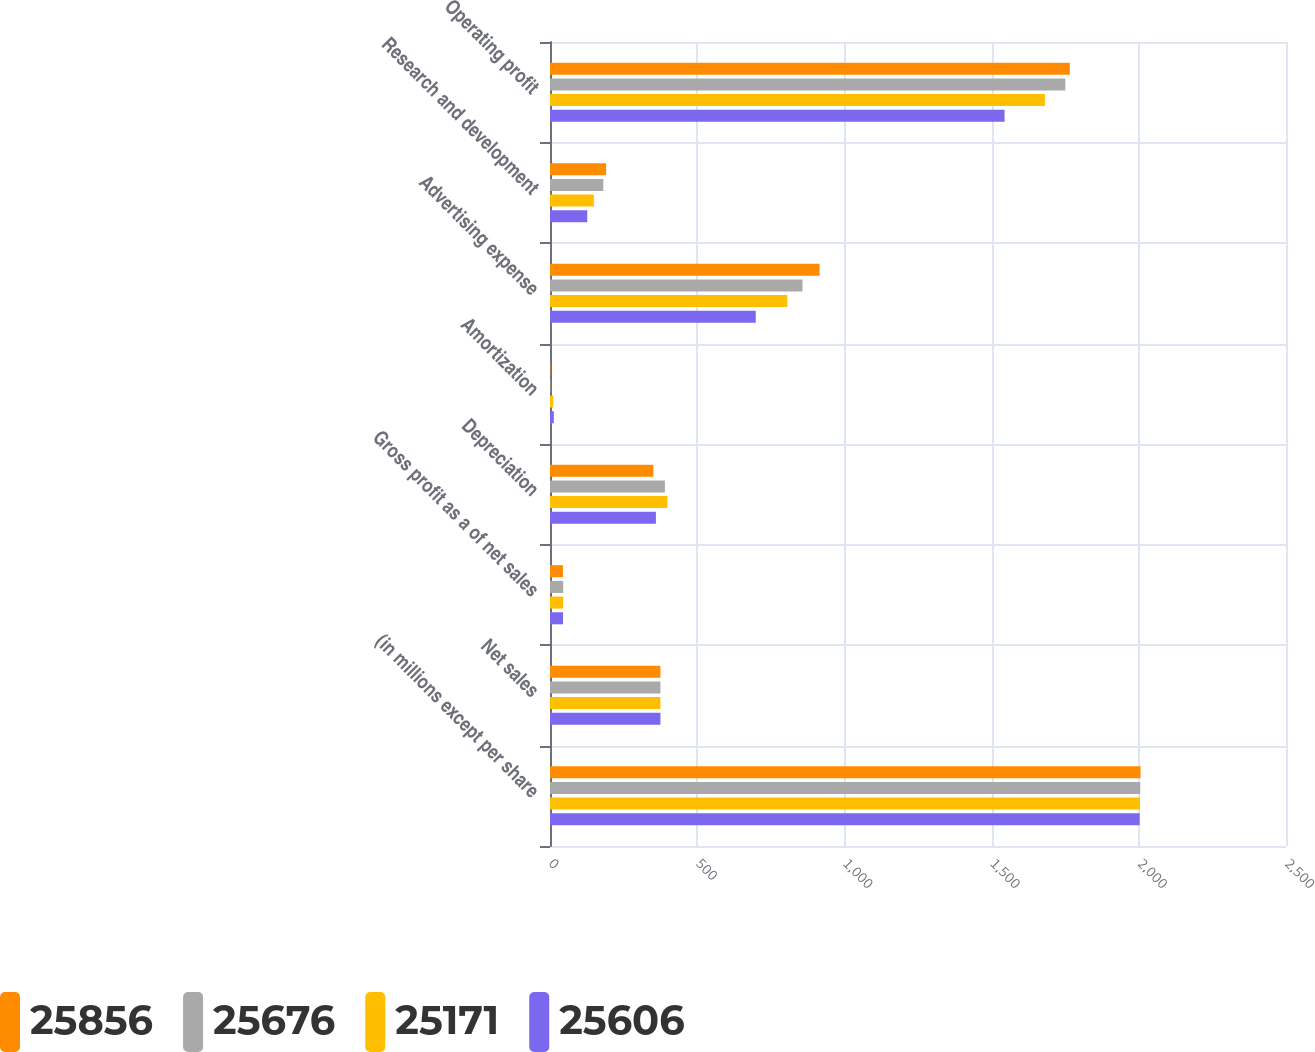Convert chart to OTSL. <chart><loc_0><loc_0><loc_500><loc_500><stacked_bar_chart><ecel><fcel>(in millions except per share<fcel>Net sales<fcel>Gross profit as a of net sales<fcel>Depreciation<fcel>Amortization<fcel>Advertising expense<fcel>Research and development<fcel>Operating profit<nl><fcel>25856<fcel>2006<fcel>375.05<fcel>44.2<fcel>351.2<fcel>1.5<fcel>915.9<fcel>190.6<fcel>1765.8<nl><fcel>25676<fcel>2005<fcel>375.05<fcel>44.9<fcel>390.3<fcel>1.5<fcel>857.7<fcel>181<fcel>1750.3<nl><fcel>25171<fcel>2004<fcel>375.05<fcel>44.9<fcel>399<fcel>11<fcel>806.2<fcel>148.9<fcel>1681.1<nl><fcel>25606<fcel>2003<fcel>375.05<fcel>44.4<fcel>359.8<fcel>13<fcel>698.9<fcel>126.7<fcel>1544.1<nl></chart> 